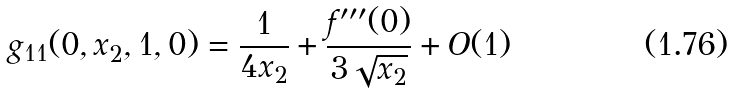Convert formula to latex. <formula><loc_0><loc_0><loc_500><loc_500>g _ { 1 1 } ( 0 , x _ { 2 } , 1 , 0 ) = \frac { 1 } { 4 x _ { 2 } } + \frac { f ^ { \prime \prime \prime } ( 0 ) } { 3 \sqrt { x _ { 2 } } } + O ( 1 )</formula> 